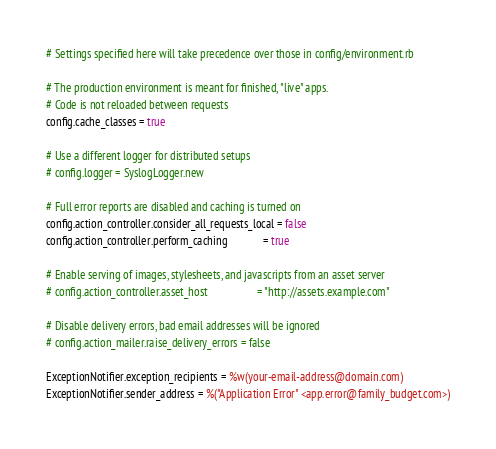<code> <loc_0><loc_0><loc_500><loc_500><_Ruby_># Settings specified here will take precedence over those in config/environment.rb

# The production environment is meant for finished, "live" apps.
# Code is not reloaded between requests
config.cache_classes = true

# Use a different logger for distributed setups
# config.logger = SyslogLogger.new

# Full error reports are disabled and caching is turned on
config.action_controller.consider_all_requests_local = false
config.action_controller.perform_caching             = true

# Enable serving of images, stylesheets, and javascripts from an asset server
# config.action_controller.asset_host                  = "http://assets.example.com"

# Disable delivery errors, bad email addresses will be ignored
# config.action_mailer.raise_delivery_errors = false

ExceptionNotifier.exception_recipients = %w(your-email-address@domain.com)
ExceptionNotifier.sender_address = %("Application Error" <app.error@family_budget.com>)
</code> 